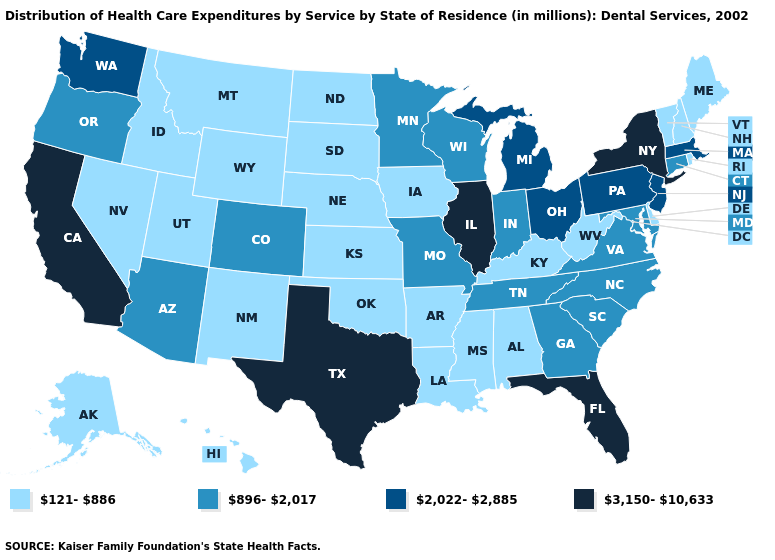Does Delaware have the same value as West Virginia?
Concise answer only. Yes. What is the value of Florida?
Answer briefly. 3,150-10,633. Among the states that border Oklahoma , which have the lowest value?
Give a very brief answer. Arkansas, Kansas, New Mexico. What is the value of Nebraska?
Write a very short answer. 121-886. Among the states that border Rhode Island , does Massachusetts have the lowest value?
Short answer required. No. What is the value of California?
Write a very short answer. 3,150-10,633. Does Pennsylvania have a lower value than New Hampshire?
Be succinct. No. Which states have the lowest value in the USA?
Give a very brief answer. Alabama, Alaska, Arkansas, Delaware, Hawaii, Idaho, Iowa, Kansas, Kentucky, Louisiana, Maine, Mississippi, Montana, Nebraska, Nevada, New Hampshire, New Mexico, North Dakota, Oklahoma, Rhode Island, South Dakota, Utah, Vermont, West Virginia, Wyoming. What is the value of Pennsylvania?
Answer briefly. 2,022-2,885. Name the states that have a value in the range 2,022-2,885?
Keep it brief. Massachusetts, Michigan, New Jersey, Ohio, Pennsylvania, Washington. Name the states that have a value in the range 2,022-2,885?
Keep it brief. Massachusetts, Michigan, New Jersey, Ohio, Pennsylvania, Washington. Among the states that border New Mexico , which have the highest value?
Be succinct. Texas. What is the highest value in the Northeast ?
Concise answer only. 3,150-10,633. Does the map have missing data?
Write a very short answer. No. Is the legend a continuous bar?
Give a very brief answer. No. 